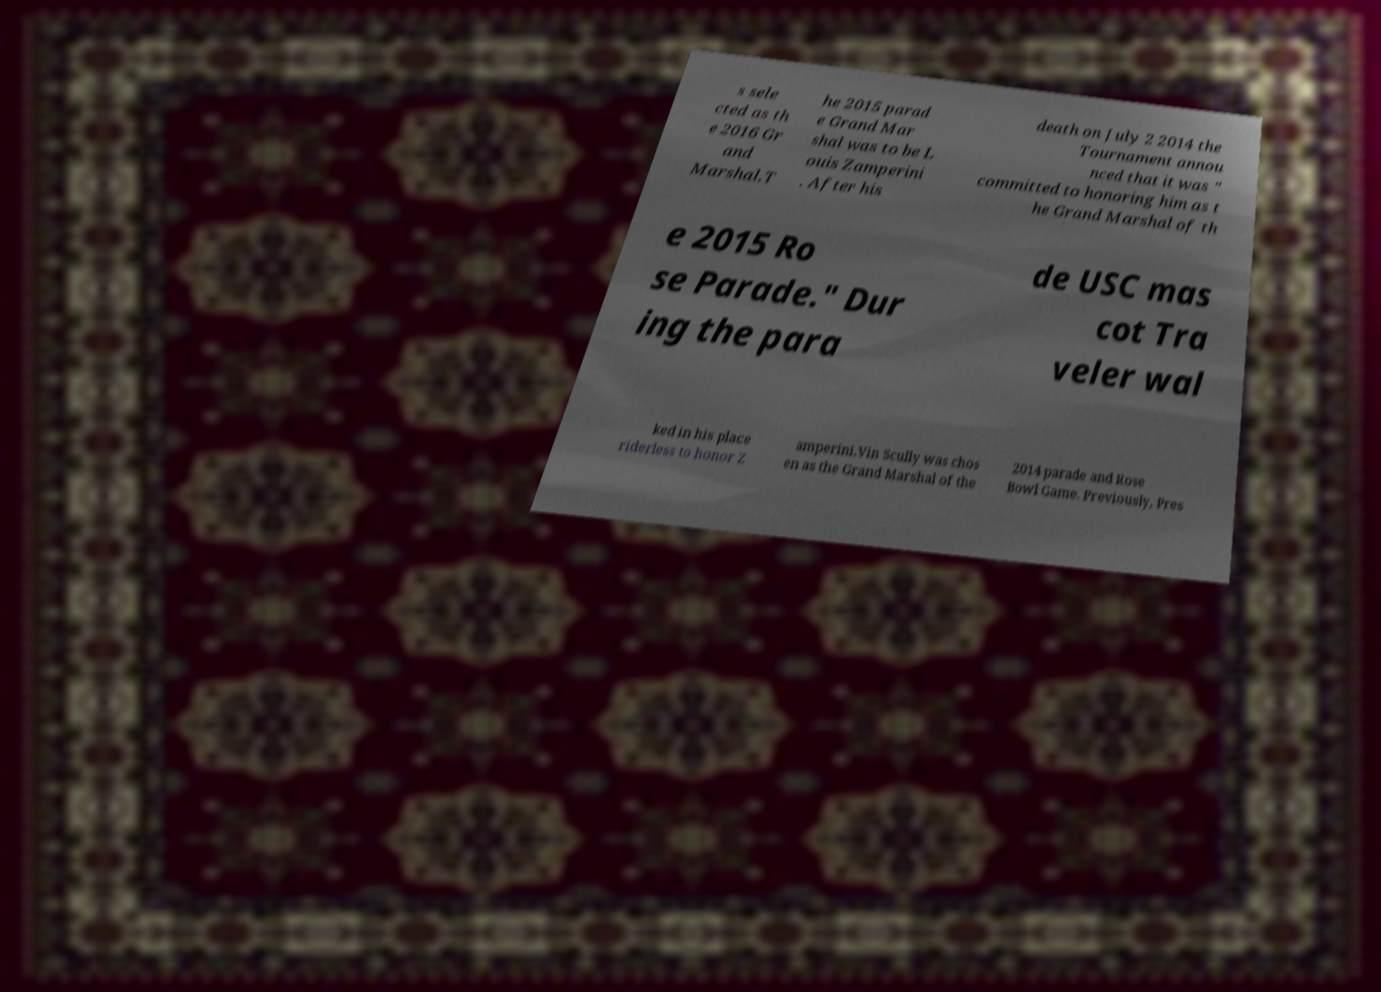Can you read and provide the text displayed in the image?This photo seems to have some interesting text. Can you extract and type it out for me? s sele cted as th e 2016 Gr and Marshal.T he 2015 parad e Grand Mar shal was to be L ouis Zamperini . After his death on July 2 2014 the Tournament annou nced that it was " committed to honoring him as t he Grand Marshal of th e 2015 Ro se Parade." Dur ing the para de USC mas cot Tra veler wal ked in his place riderless to honor Z amperini.Vin Scully was chos en as the Grand Marshal of the 2014 parade and Rose Bowl Game. Previously, Pres 